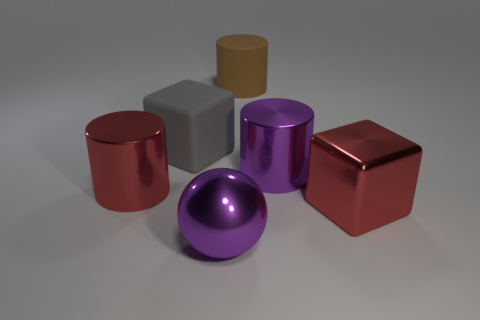How many other things are the same color as the metallic ball?
Provide a succinct answer. 1. Is there another purple ball of the same size as the shiny sphere?
Provide a short and direct response. No. What is the material of the gray object that is the same size as the red cylinder?
Keep it short and to the point. Rubber. There is a brown cylinder; is it the same size as the cylinder that is on the right side of the big rubber cylinder?
Make the answer very short. Yes. How many rubber things are big gray blocks or tiny purple cylinders?
Offer a very short reply. 1. How many other big objects have the same shape as the big brown matte object?
Make the answer very short. 2. What material is the thing that is the same color as the large metallic sphere?
Make the answer very short. Metal. Do the metallic object that is to the left of the ball and the red thing that is right of the rubber cube have the same size?
Make the answer very short. Yes. The rubber object left of the big matte cylinder has what shape?
Give a very brief answer. Cube. What material is the other thing that is the same shape as the large gray rubber thing?
Your response must be concise. Metal. 